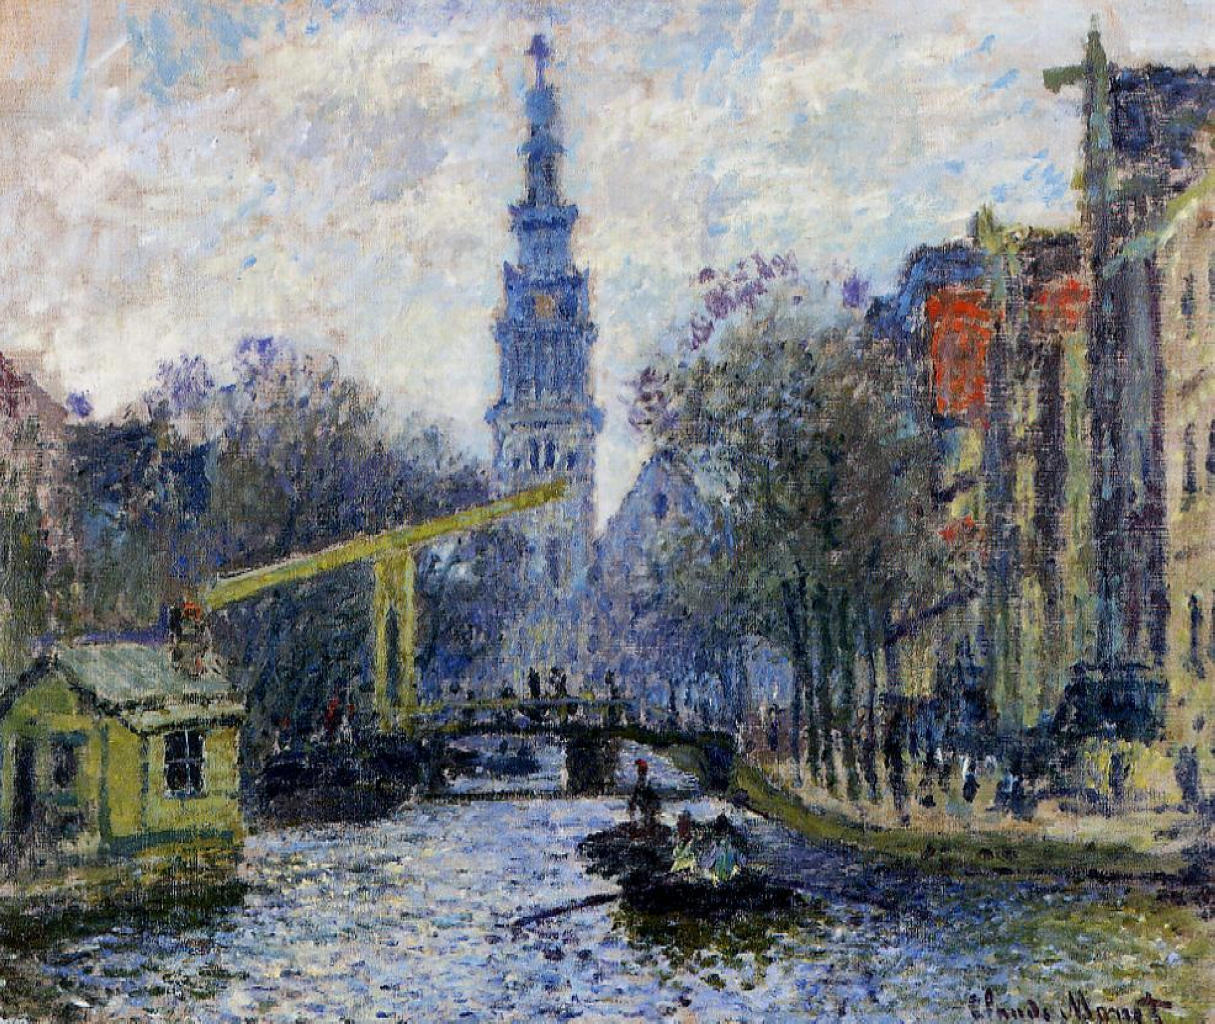Can you describe the main features of this image for me? The image represents a captivating impressionist painting by Claude Monet, depicting a serene cityscape with a canal and a bridge. The artist employed a loose, sketchy style, emphasizing the interplay of colors and the overall atmosphere over fine details. The painting is dominated by hues of blue, green, and yellow, creating a harmonious and vibrant palette.

The scene shows a light blue sky with scattered white clouds, suggesting a calm, early day. The canal's water mirrors this deep blue, with white reflections dancing on the surface. A pale yellow bridge crosses the canal, offering a striking contrast against the blue tones. Buildings with a mix of red, orange, and green hues line the canal, their colorful facades reflected in the water. In the lower right corner, the signature 'Claude Monet' indicates the celebrated French impressionist artist. The composition, color scheme, and brushwork are characteristic of Monet's style and the impressionist genre, beautifully encapsulating the fleeting effects of light and color. 